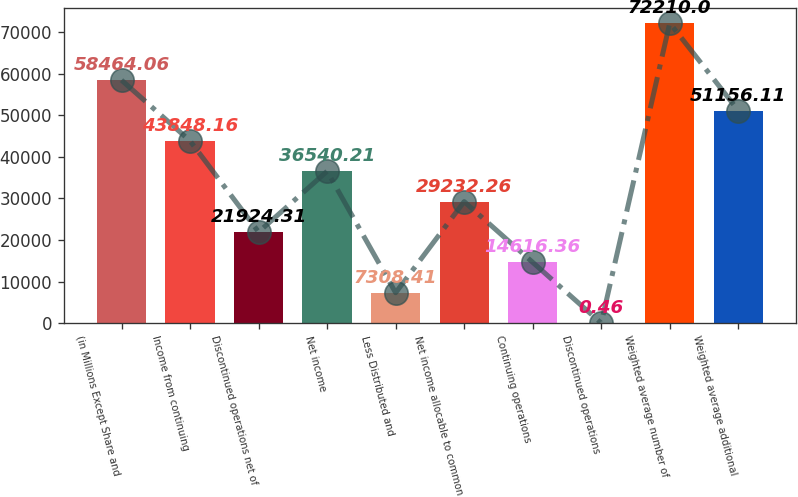Convert chart. <chart><loc_0><loc_0><loc_500><loc_500><bar_chart><fcel>(in Millions Except Share and<fcel>Income from continuing<fcel>Discontinued operations net of<fcel>Net income<fcel>Less Distributed and<fcel>Net income allocable to common<fcel>Continuing operations<fcel>Discontinued operations<fcel>Weighted average number of<fcel>Weighted average additional<nl><fcel>58464.1<fcel>43848.2<fcel>21924.3<fcel>36540.2<fcel>7308.41<fcel>29232.3<fcel>14616.4<fcel>0.46<fcel>72210<fcel>51156.1<nl></chart> 